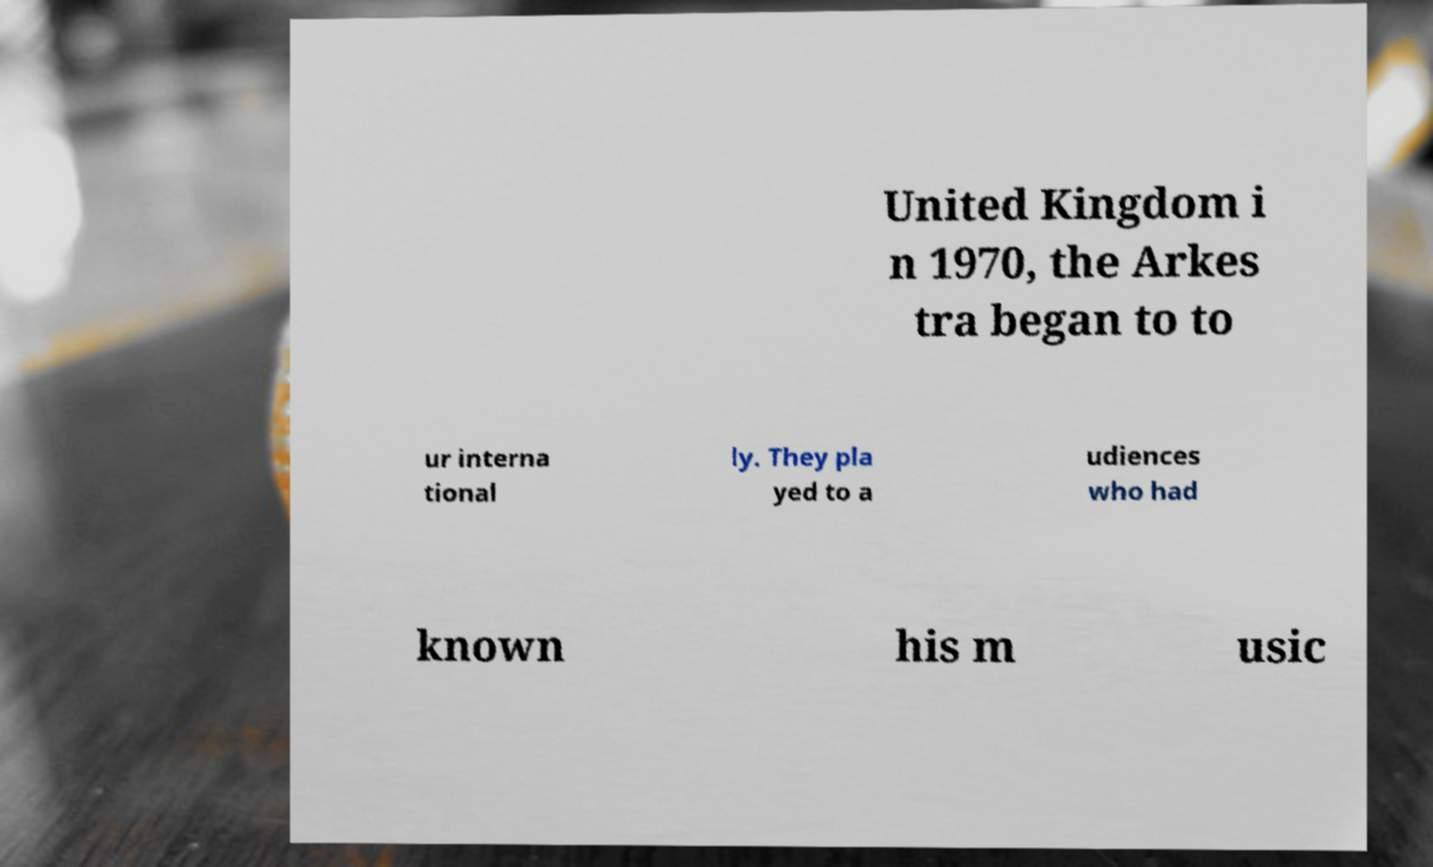Can you read and provide the text displayed in the image?This photo seems to have some interesting text. Can you extract and type it out for me? United Kingdom i n 1970, the Arkes tra began to to ur interna tional ly. They pla yed to a udiences who had known his m usic 